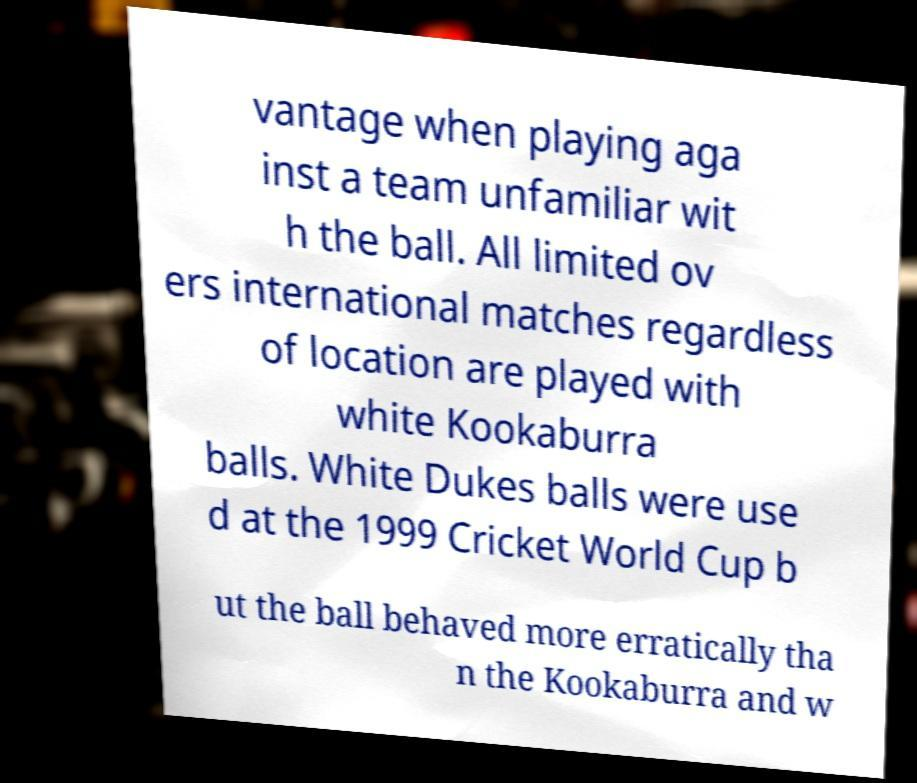Could you assist in decoding the text presented in this image and type it out clearly? vantage when playing aga inst a team unfamiliar wit h the ball. All limited ov ers international matches regardless of location are played with white Kookaburra balls. White Dukes balls were use d at the 1999 Cricket World Cup b ut the ball behaved more erratically tha n the Kookaburra and w 